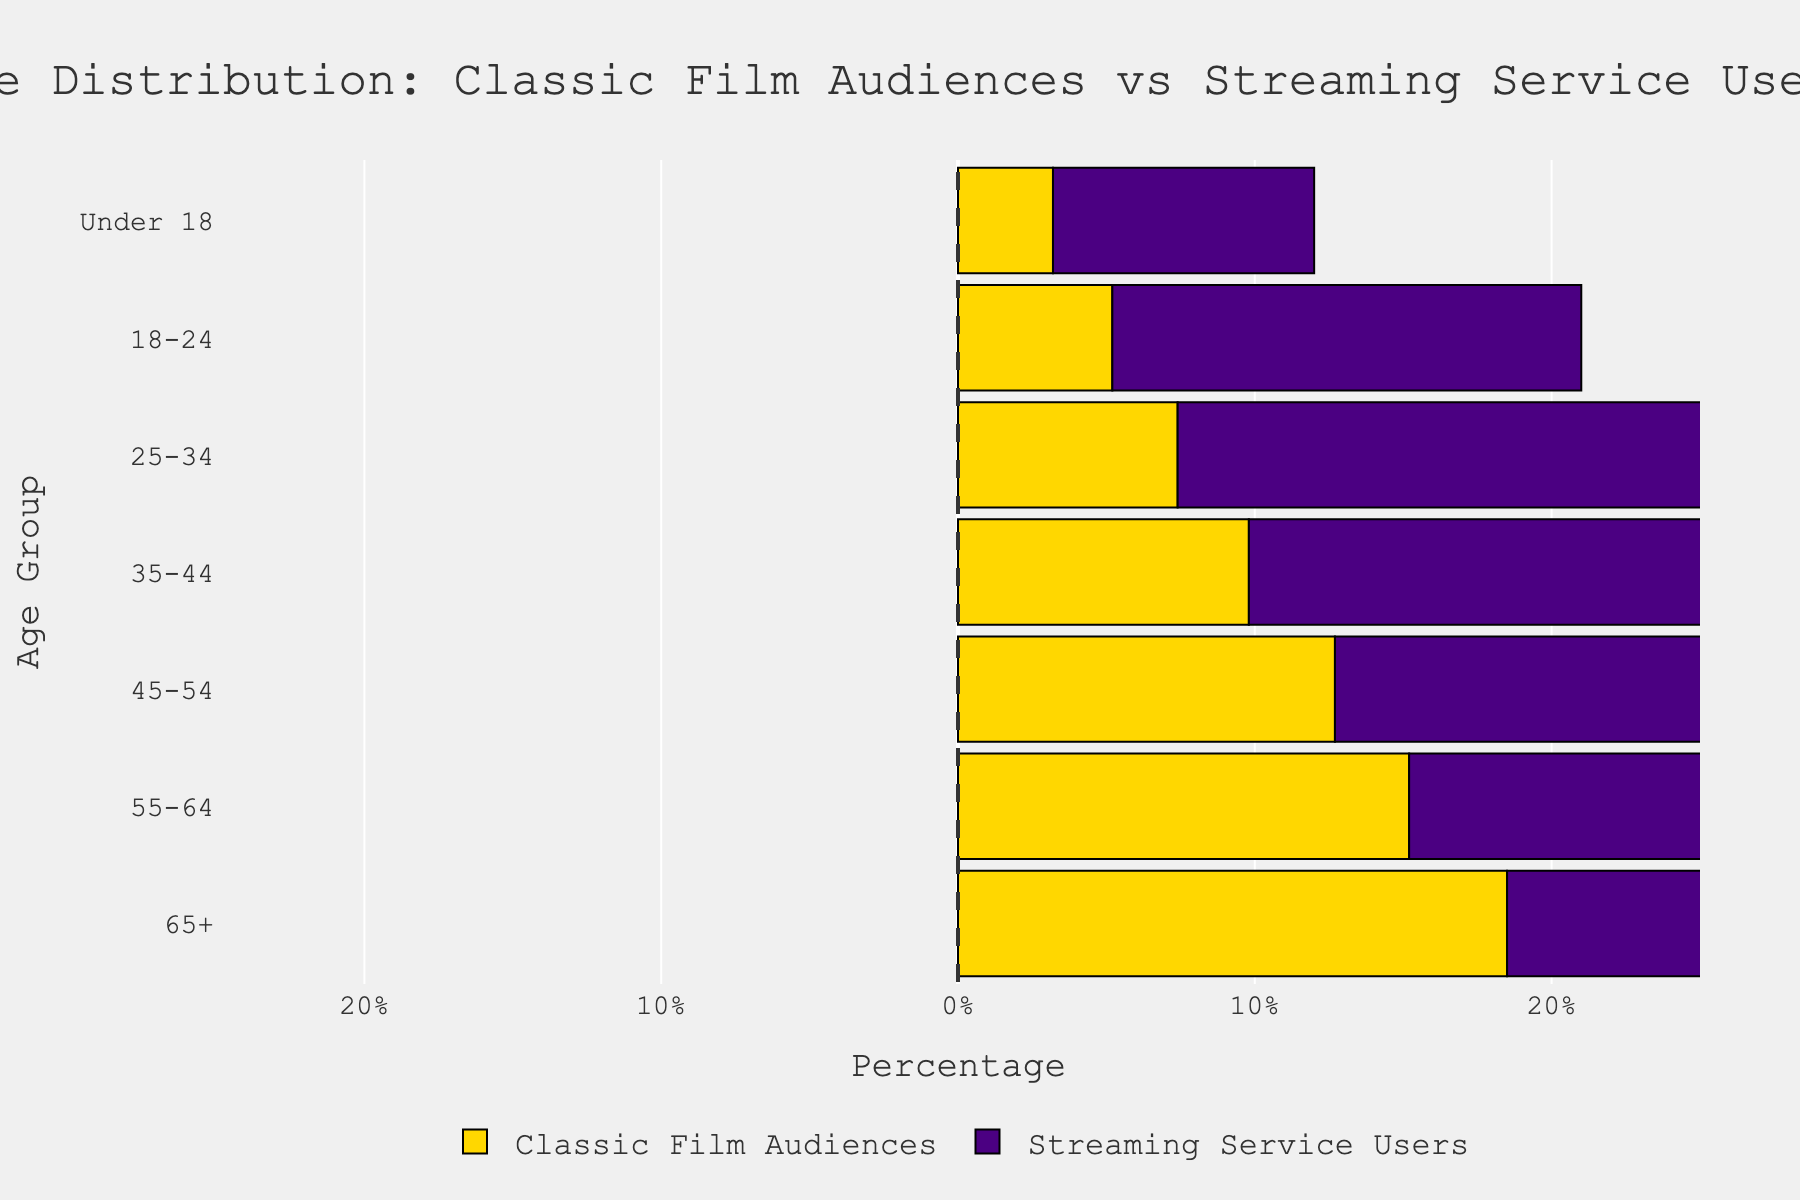What age group has the highest percentage of classic film audiences? To find the answer, look at the data for Classic Film Audiences on the left side of the chart. The age group with the highest bar represents the highest percentage.
Answer: 65+ What is the percentage difference between the 18-24 and 65+ age groups for classic film audiences? Look at the classic film audiences data for the 18-24 and 65+ age groups. Subtract the smaller percentage from the larger one: 18.5 - 5.2 = 13.3%.
Answer: 13.3% Which age group has the lowest percentage of streaming service users? Observe the streaming service users on the right side of the chart. The 25-34 age group has the longest bar, indicating the lowest percentage (negative value).
Answer: 25-34 Compare the percentage of classic film audiences to streaming service users for the age group 55-64. For the age group 55-64, look at the left bar for classic film audiences (15.2%) and the right bar for streaming service users (-10.8% or 10.8% for comparison). Classic film audiences have a higher percentage.
Answer: Classic film audiences have a higher percentage What is the difference in percentage between classic film audiences and streaming service users for the 45-54 age group? Compare the 45-54 age group's percentages for both categories: classic film audiences (12.7%) and streaming service users (-14.5% or 14.5%). Subtract the smaller one from the larger: 14.5 - 12.7 = 1.8%.
Answer: 1.8% Which age group has a higher overall percentage of viewers when combining classic film audiences and streaming service users? Add the percentages for both categories in each age group and compare the combined values. The age group 65+ has the highest combined percentage: 18.5% + 12.3% = 30.8%.
Answer: 65+ How does the percentage of classic film audiences for Under 18 compare to that of streaming service users? Compare the percentages for the Under 18 age group: classic film audiences (3.2%) and streaming service users (-8.8% or 8.8%). Classic film audiences have a lower percentage.
Answer: Classic film audiences have a lower percentage What is the total percentage for classic film audiences across all age groups? Add the percentages for classic film audiences across all age groups: 3.2 + 5.2 + 7.4 + 9.8 + 12.7 + 15.2 + 18.5 = 72%.
Answer: 72% Which age group shows the greatest difference in percentages between classic film audiences and streaming service users? Subtract the percentages of streaming service users (taking the absolute value of the negative) from classic film audiences for each age group and identify the largest difference. The 25-34 age group has the greatest difference: 20.6 - 7.4 = 13.2%.
Answer: 25-34 For the 35-44 age group, how do the percentages of classic film audiences and streaming service users change relative to each other? Look at the percentages for the 35-44 age group: classic film audiences (9.8%) and streaming service users (-17.2% or 17.2%). The percentage difference is 17.2 - 9.8 = 7.4%, with streaming users having a higher percentage.
Answer: Streaming service users have a higher percentage 